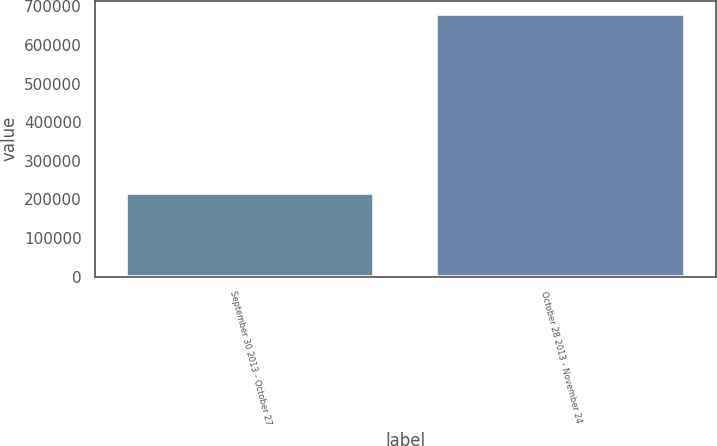Convert chart to OTSL. <chart><loc_0><loc_0><loc_500><loc_500><bar_chart><fcel>September 30 2013 - October 27<fcel>October 28 2013 - November 24<nl><fcel>216631<fcel>680142<nl></chart> 